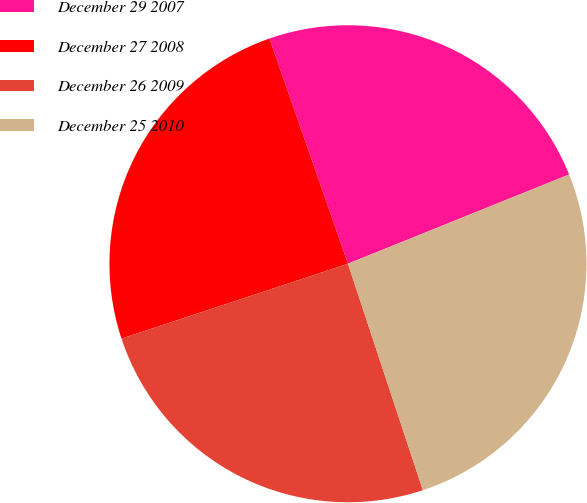Convert chart to OTSL. <chart><loc_0><loc_0><loc_500><loc_500><pie_chart><fcel>December 29 2007<fcel>December 27 2008<fcel>December 26 2009<fcel>December 25 2010<nl><fcel>24.23%<fcel>24.74%<fcel>25.0%<fcel>26.02%<nl></chart> 